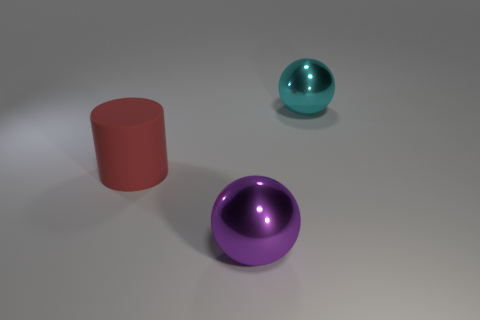Add 2 large shiny things. How many objects exist? 5 Subtract 1 balls. How many balls are left? 1 Subtract all cyan balls. How many balls are left? 1 Subtract all balls. How many objects are left? 1 Add 2 purple balls. How many purple balls exist? 3 Subtract 0 purple cubes. How many objects are left? 3 Subtract all purple spheres. Subtract all yellow cylinders. How many spheres are left? 1 Subtract all green blocks. How many red spheres are left? 0 Subtract all big cyan metal things. Subtract all small red matte spheres. How many objects are left? 2 Add 1 purple metal things. How many purple metal things are left? 2 